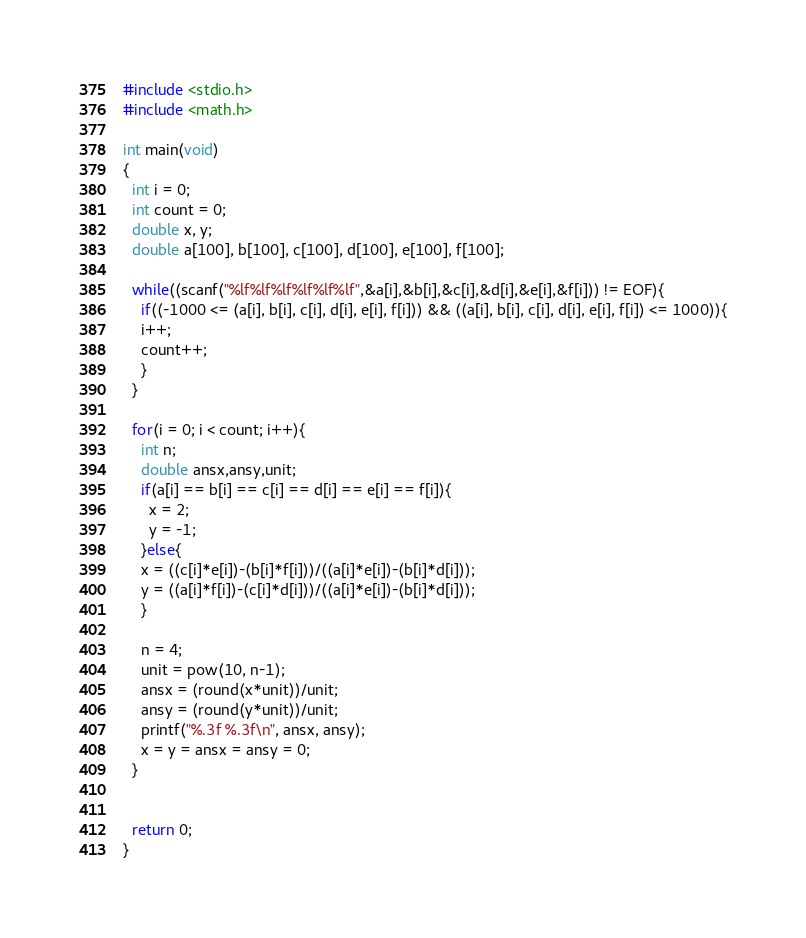Convert code to text. <code><loc_0><loc_0><loc_500><loc_500><_C_>#include <stdio.h>
#include <math.h>

int main(void)
{
  int i = 0;
  int count = 0;
  double x, y;
  double a[100], b[100], c[100], d[100], e[100], f[100];

  while((scanf("%lf%lf%lf%lf%lf%lf",&a[i],&b[i],&c[i],&d[i],&e[i],&f[i])) != EOF){
    if((-1000 <= (a[i], b[i], c[i], d[i], e[i], f[i])) && ((a[i], b[i], c[i], d[i], e[i], f[i]) <= 1000)){
    i++;
    count++;
    }
  }

  for(i = 0; i < count; i++){
    int n;
    double ansx,ansy,unit;
    if(a[i] == b[i] == c[i] == d[i] == e[i] == f[i]){
      x = 2;
      y = -1;
    }else{
    x = ((c[i]*e[i])-(b[i]*f[i]))/((a[i]*e[i])-(b[i]*d[i]));
    y = ((a[i]*f[i])-(c[i]*d[i]))/((a[i]*e[i])-(b[i]*d[i]));
    }

    n = 4;
    unit = pow(10, n-1);
    ansx = (round(x*unit))/unit;
    ansy = (round(y*unit))/unit;
    printf("%.3f %.3f\n", ansx, ansy);
    x = y = ansx = ansy = 0;
  }
  

  return 0;
}</code> 